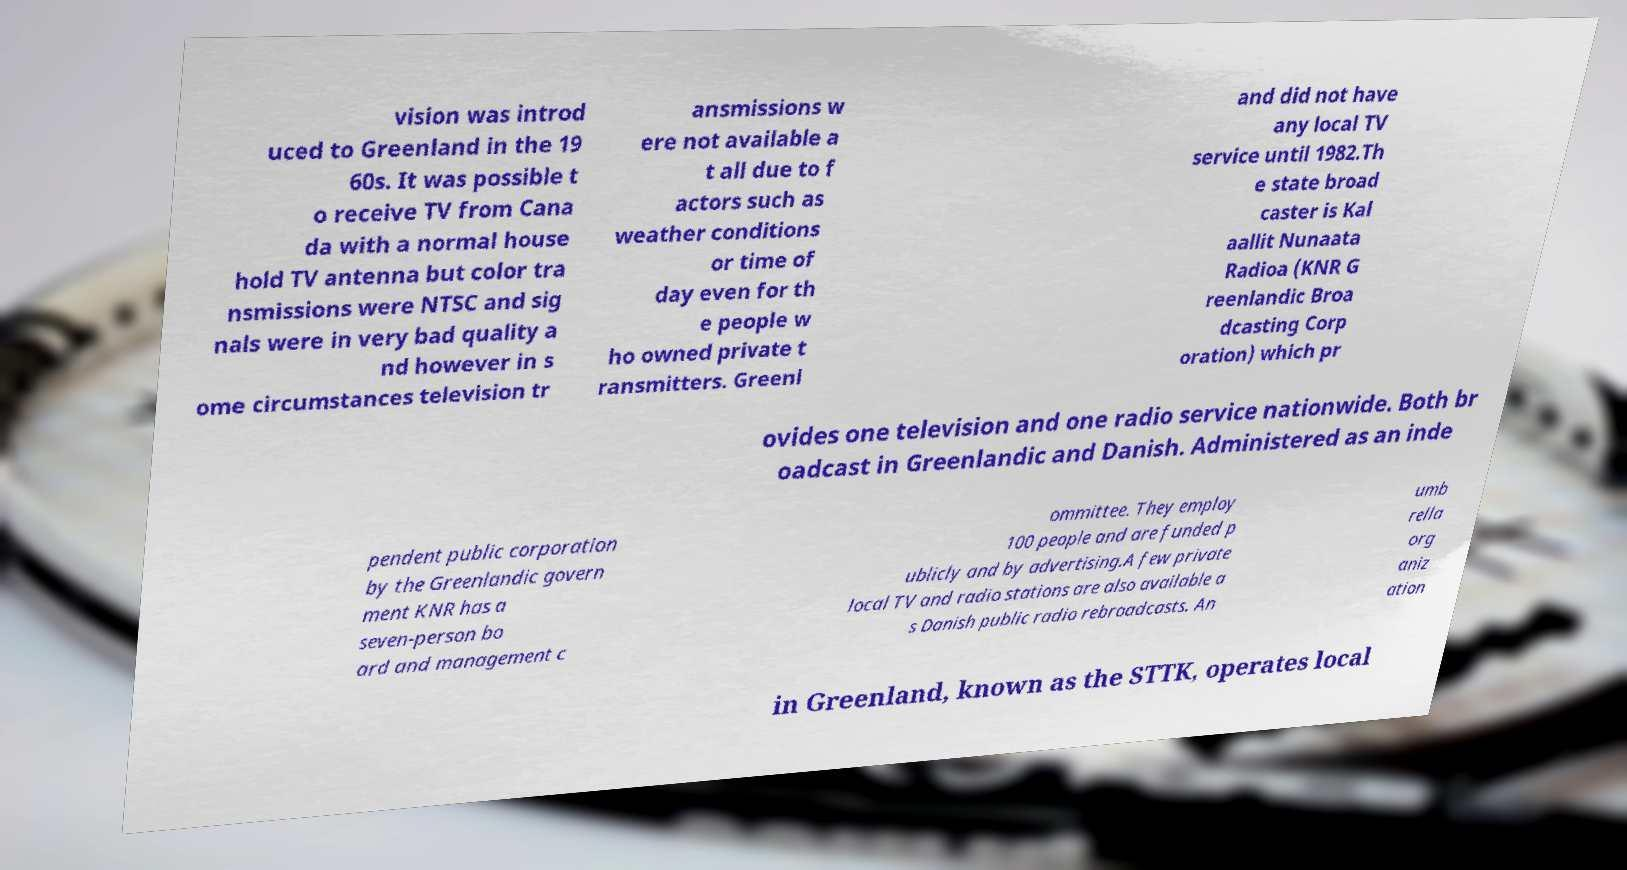For documentation purposes, I need the text within this image transcribed. Could you provide that? vision was introd uced to Greenland in the 19 60s. It was possible t o receive TV from Cana da with a normal house hold TV antenna but color tra nsmissions were NTSC and sig nals were in very bad quality a nd however in s ome circumstances television tr ansmissions w ere not available a t all due to f actors such as weather conditions or time of day even for th e people w ho owned private t ransmitters. Greenl and did not have any local TV service until 1982.Th e state broad caster is Kal aallit Nunaata Radioa (KNR G reenlandic Broa dcasting Corp oration) which pr ovides one television and one radio service nationwide. Both br oadcast in Greenlandic and Danish. Administered as an inde pendent public corporation by the Greenlandic govern ment KNR has a seven-person bo ard and management c ommittee. They employ 100 people and are funded p ublicly and by advertising.A few private local TV and radio stations are also available a s Danish public radio rebroadcasts. An umb rella org aniz ation in Greenland, known as the STTK, operates local 